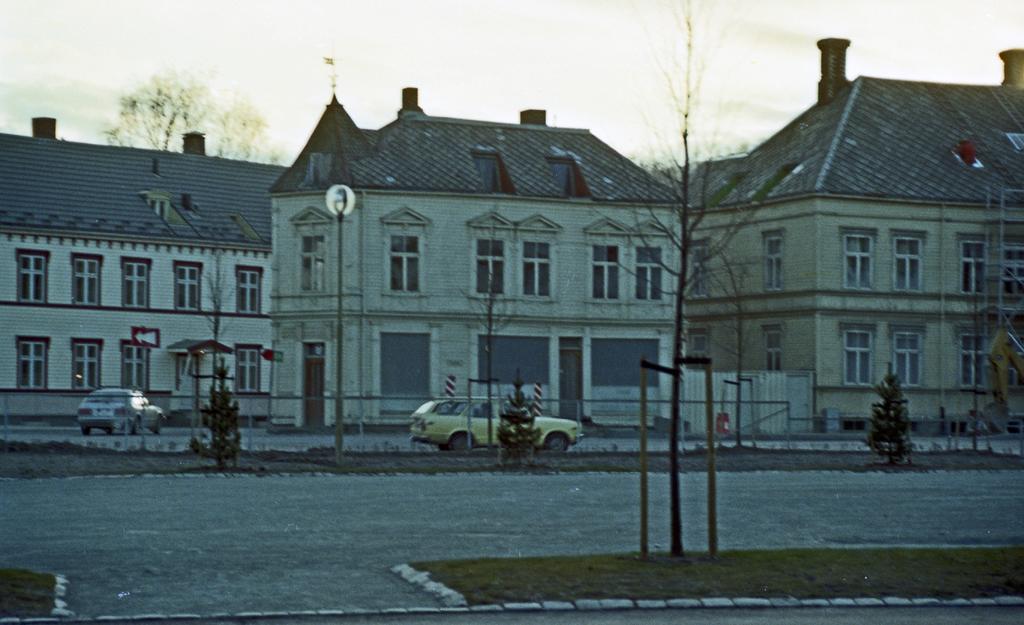Can you describe this image briefly? In this picture we can see vehicles on the road and in the background we can see buildings, trees, poles and the sky. 